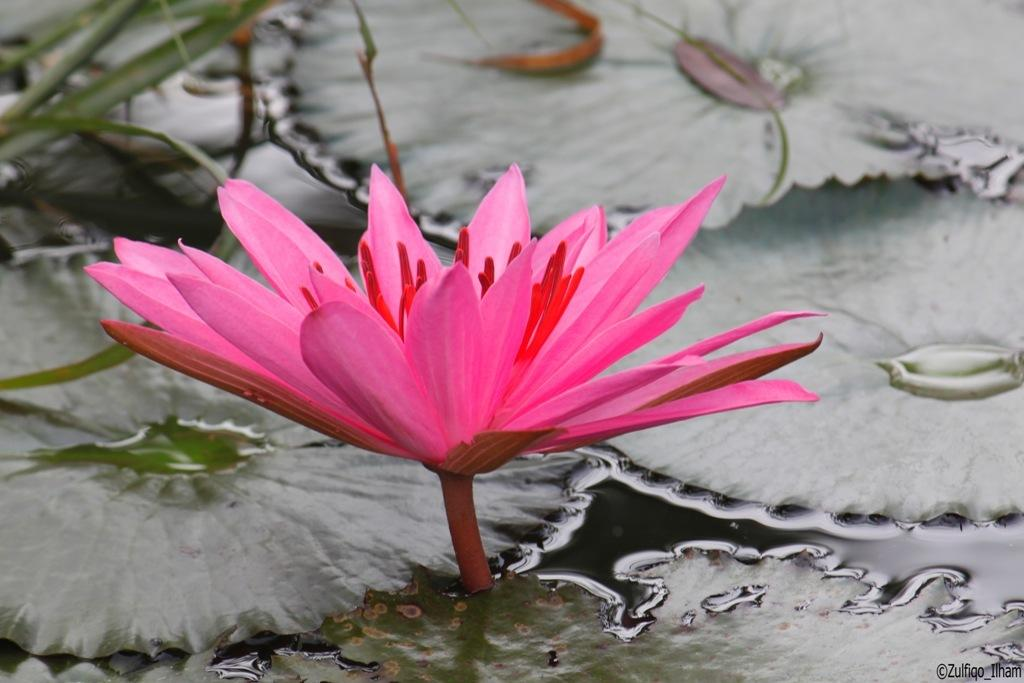What is the main subject of the image? There is a flower in the image. What is beneath the flower? There is a water surface under the flower. What else can be seen around the flower? There are large leaves around the flower. Where is the tin located in the image? There is no tin present in the image. How many sheep are visible in the image? There are no sheep present in the image. 